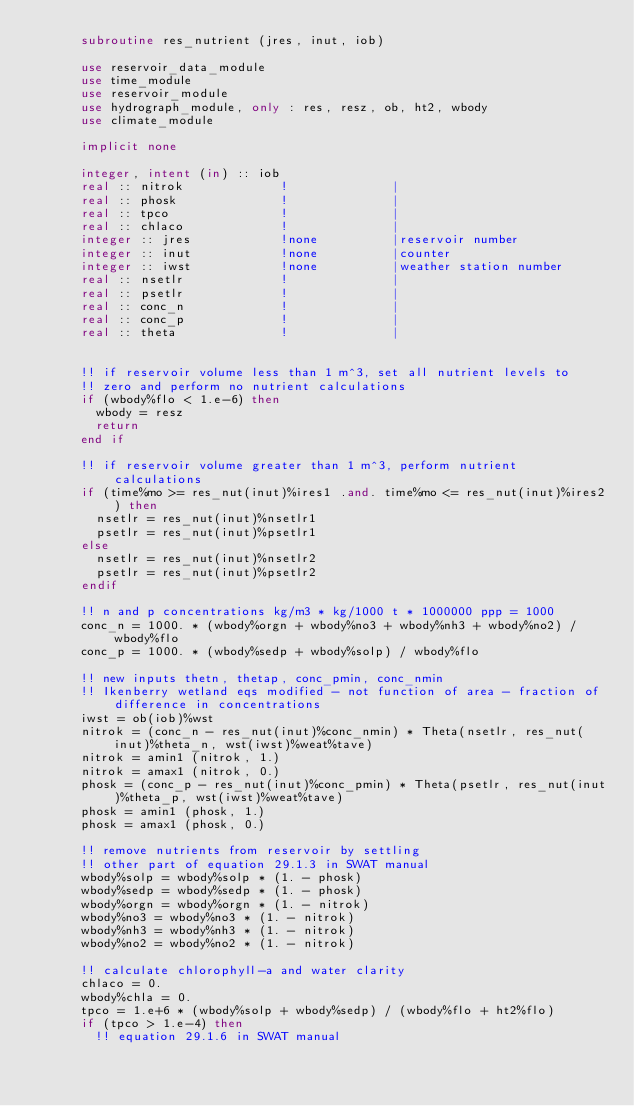<code> <loc_0><loc_0><loc_500><loc_500><_FORTRAN_>      subroutine res_nutrient (jres, inut, iob)

      use reservoir_data_module
      use time_module
      use reservoir_module
      use hydrograph_module, only : res, resz, ob, ht2, wbody
      use climate_module
      
      implicit none      
      
      integer, intent (in) :: iob
      real :: nitrok             !              |
      real :: phosk              !              |
      real :: tpco               !              |
      real :: chlaco             !              |
      integer :: jres            !none          |reservoir number
      integer :: inut            !none          |counter
      integer :: iwst            !none          |weather station number
      real :: nsetlr             !              |
      real :: psetlr             !              |
      real :: conc_n             !              |
      real :: conc_p             !              |
      real :: theta              !              |
      

      !! if reservoir volume less than 1 m^3, set all nutrient levels to
      !! zero and perform no nutrient calculations
      if (wbody%flo < 1.e-6) then
        wbody = resz
        return
      end if

      !! if reservoir volume greater than 1 m^3, perform nutrient calculations
      if (time%mo >= res_nut(inut)%ires1 .and. time%mo <= res_nut(inut)%ires2) then
        nsetlr = res_nut(inut)%nsetlr1
        psetlr = res_nut(inut)%psetlr1
      else
        nsetlr = res_nut(inut)%nsetlr2
        psetlr = res_nut(inut)%psetlr2
      endif

      !! n and p concentrations kg/m3 * kg/1000 t * 1000000 ppp = 1000
      conc_n = 1000. * (wbody%orgn + wbody%no3 + wbody%nh3 + wbody%no2) / wbody%flo
      conc_p = 1000. * (wbody%sedp + wbody%solp) / wbody%flo
      
      !! new inputs thetn, thetap, conc_pmin, conc_nmin
      !! Ikenberry wetland eqs modified - not function of area - fraction of difference in concentrations
      iwst = ob(iob)%wst
      nitrok = (conc_n - res_nut(inut)%conc_nmin) * Theta(nsetlr, res_nut(inut)%theta_n, wst(iwst)%weat%tave)
      nitrok = amin1 (nitrok, 1.)
      nitrok = amax1 (nitrok, 0.)
      phosk = (conc_p - res_nut(inut)%conc_pmin) * Theta(psetlr, res_nut(inut)%theta_p, wst(iwst)%weat%tave)
      phosk = amin1 (phosk, 1.)
      phosk = amax1 (phosk, 0.)

      !! remove nutrients from reservoir by settling
      !! other part of equation 29.1.3 in SWAT manual
      wbody%solp = wbody%solp * (1. - phosk)
      wbody%sedp = wbody%sedp * (1. - phosk)
      wbody%orgn = wbody%orgn * (1. - nitrok)
      wbody%no3 = wbody%no3 * (1. - nitrok)
      wbody%nh3 = wbody%nh3 * (1. - nitrok)
      wbody%no2 = wbody%no2 * (1. - nitrok)

      !! calculate chlorophyll-a and water clarity
      chlaco = 0.
      wbody%chla = 0.
      tpco = 1.e+6 * (wbody%solp + wbody%sedp) / (wbody%flo + ht2%flo)
      if (tpco > 1.e-4) then
        !! equation 29.1.6 in SWAT manual</code> 